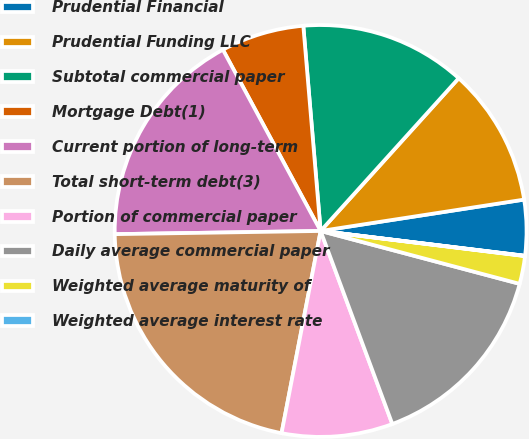Convert chart to OTSL. <chart><loc_0><loc_0><loc_500><loc_500><pie_chart><fcel>Prudential Financial<fcel>Prudential Funding LLC<fcel>Subtotal commercial paper<fcel>Mortgage Debt(1)<fcel>Current portion of long-term<fcel>Total short-term debt(3)<fcel>Portion of commercial paper<fcel>Daily average commercial paper<fcel>Weighted average maturity of<fcel>Weighted average interest rate<nl><fcel>4.36%<fcel>10.87%<fcel>13.04%<fcel>6.53%<fcel>17.38%<fcel>21.72%<fcel>8.7%<fcel>15.21%<fcel>2.19%<fcel>0.02%<nl></chart> 